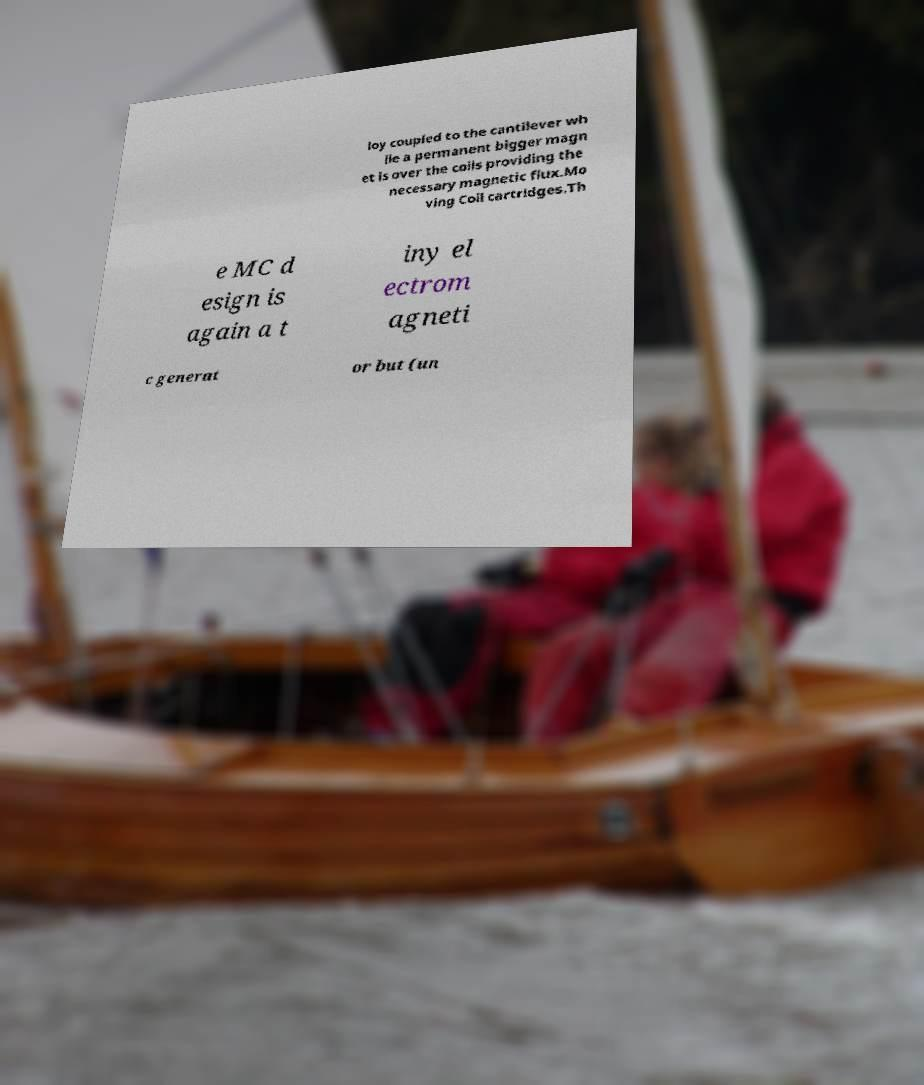For documentation purposes, I need the text within this image transcribed. Could you provide that? loy coupled to the cantilever wh ile a permanent bigger magn et is over the coils providing the necessary magnetic flux.Mo ving Coil cartridges.Th e MC d esign is again a t iny el ectrom agneti c generat or but (un 